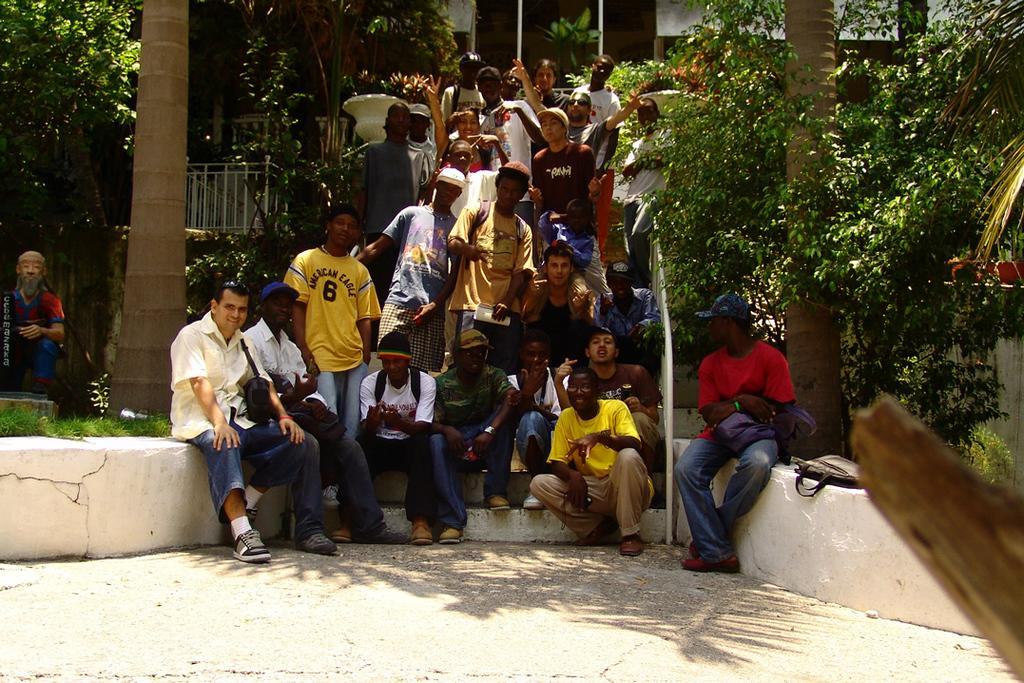How many people are in the image? There is a group of people in the image, but the exact number cannot be determined from the provided facts. What are some people doing in the image? Some people are standing on a staircase, while others are sitting. What type of natural environment is visible in the image? There are trees and grass in the image. What type of structure is present in the image? There is a building in the image. What type of riddle is being solved by the people in the image? There is no indication in the image that the people are solving a riddle. What type of business is being conducted by the people in the image? There is no indication in the image that the people are conducting any business. 